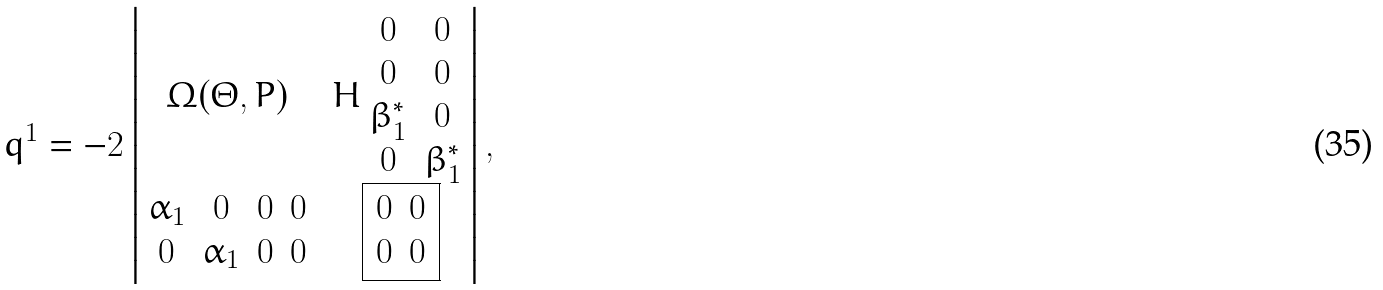Convert formula to latex. <formula><loc_0><loc_0><loc_500><loc_500>q ^ { 1 } = - 2 \begin{vmatrix} \Omega ( \Theta , P ) & H \begin{array} { c c } 0 & 0 \\ 0 & 0 \\ \beta _ { 1 } ^ { * } & 0 \\ 0 & \beta _ { 1 } ^ { * } \end{array} \\ \begin{array} { c c c c } \alpha _ { 1 } & 0 & 0 & 0 \\ 0 & \alpha _ { 1 } & 0 & 0 \end{array} & \boxed { \begin{array} { c c } 0 & 0 \\ 0 & 0 \end{array} } \end{vmatrix} ,</formula> 